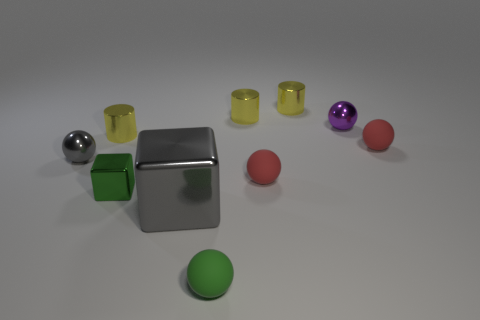Is the big block the same color as the tiny metallic cube?
Keep it short and to the point. No. Is the number of gray metallic things less than the number of purple shiny things?
Your answer should be compact. No. Are there any small yellow metal things to the right of the large gray metal cube?
Your answer should be very brief. Yes. Is the material of the gray cube the same as the gray ball?
Your answer should be compact. Yes. There is another metal object that is the same shape as the small gray object; what is its color?
Give a very brief answer. Purple. Is the color of the tiny metal sphere right of the tiny gray thing the same as the small cube?
Ensure brevity in your answer.  No. There is a small metallic object that is the same color as the large metallic thing; what is its shape?
Your answer should be compact. Sphere. What number of blue cylinders have the same material as the big gray thing?
Keep it short and to the point. 0. How many tiny green shiny blocks are in front of the green shiny object?
Offer a terse response. 0. How big is the purple shiny thing?
Keep it short and to the point. Small. 